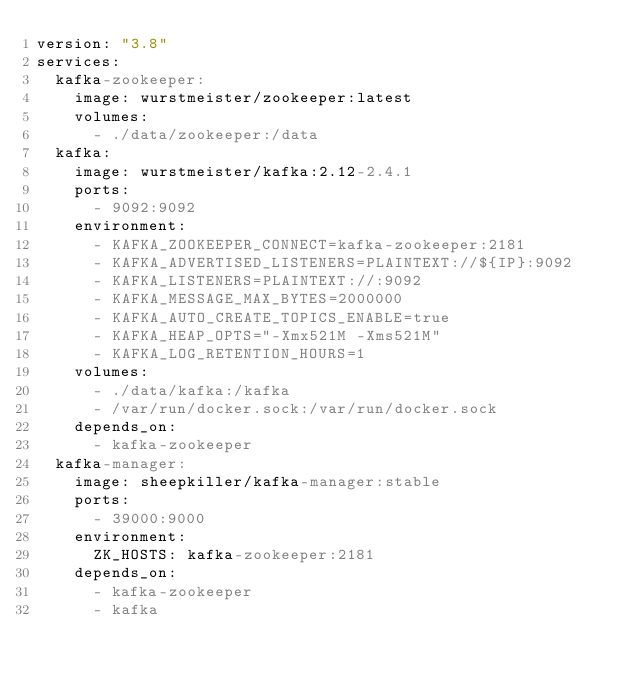<code> <loc_0><loc_0><loc_500><loc_500><_YAML_>version: "3.8"
services:
  kafka-zookeeper:
    image: wurstmeister/zookeeper:latest
    volumes:
      - ./data/zookeeper:/data
  kafka:
    image: wurstmeister/kafka:2.12-2.4.1
    ports:
      - 9092:9092
    environment:
      - KAFKA_ZOOKEEPER_CONNECT=kafka-zookeeper:2181
      - KAFKA_ADVERTISED_LISTENERS=PLAINTEXT://${IP}:9092
      - KAFKA_LISTENERS=PLAINTEXT://:9092
      - KAFKA_MESSAGE_MAX_BYTES=2000000
      - KAFKA_AUTO_CREATE_TOPICS_ENABLE=true
      - KAFKA_HEAP_OPTS="-Xmx521M -Xms521M"
      - KAFKA_LOG_RETENTION_HOURS=1
    volumes:
      - ./data/kafka:/kafka
      - /var/run/docker.sock:/var/run/docker.sock
    depends_on:
      - kafka-zookeeper
  kafka-manager:
    image: sheepkiller/kafka-manager:stable
    ports:
      - 39000:9000
    environment:
      ZK_HOSTS: kafka-zookeeper:2181
    depends_on:
      - kafka-zookeeper
      - kafka</code> 